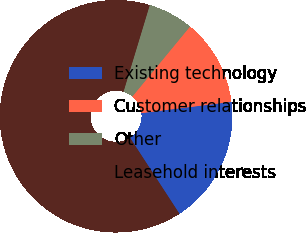Convert chart. <chart><loc_0><loc_0><loc_500><loc_500><pie_chart><fcel>Existing technology<fcel>Customer relationships<fcel>Other<fcel>Leasehold interests<nl><fcel>17.81%<fcel>12.05%<fcel>6.29%<fcel>63.85%<nl></chart> 